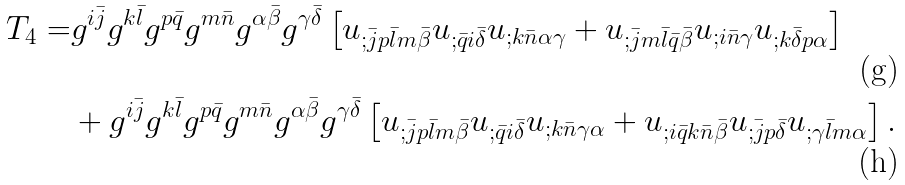Convert formula to latex. <formula><loc_0><loc_0><loc_500><loc_500>T _ { 4 } = & g ^ { i \bar { j } } g ^ { k \bar { l } } g ^ { p \bar { q } } g ^ { m \bar { n } } g ^ { \alpha \bar { \beta } } g ^ { \gamma \bar { \delta } } \left [ u _ { ; \bar { j } p \bar { l } m \bar { \beta } } u _ { ; \bar { q } i \bar { \delta } } u _ { ; k \bar { n } \alpha \gamma } + u _ { ; \bar { j } m \bar { l } \bar { q } \bar { \beta } } u _ { ; i \bar { n } \gamma } u _ { ; k \bar { \delta } p \alpha } \right ] \\ & + g ^ { i \bar { j } } g ^ { k \bar { l } } g ^ { p \bar { q } } g ^ { m \bar { n } } g ^ { \alpha \bar { \beta } } g ^ { \gamma \bar { \delta } } \left [ u _ { ; \bar { j } p \bar { l } m \bar { \beta } } u _ { ; \bar { q } i \bar { \delta } } u _ { ; k \bar { n } \gamma \alpha } + u _ { ; i \bar { q } k \bar { n } \bar { \beta } } u _ { ; \bar { j } p \bar { \delta } } u _ { ; \gamma \bar { l } m \alpha } \right ] .</formula> 